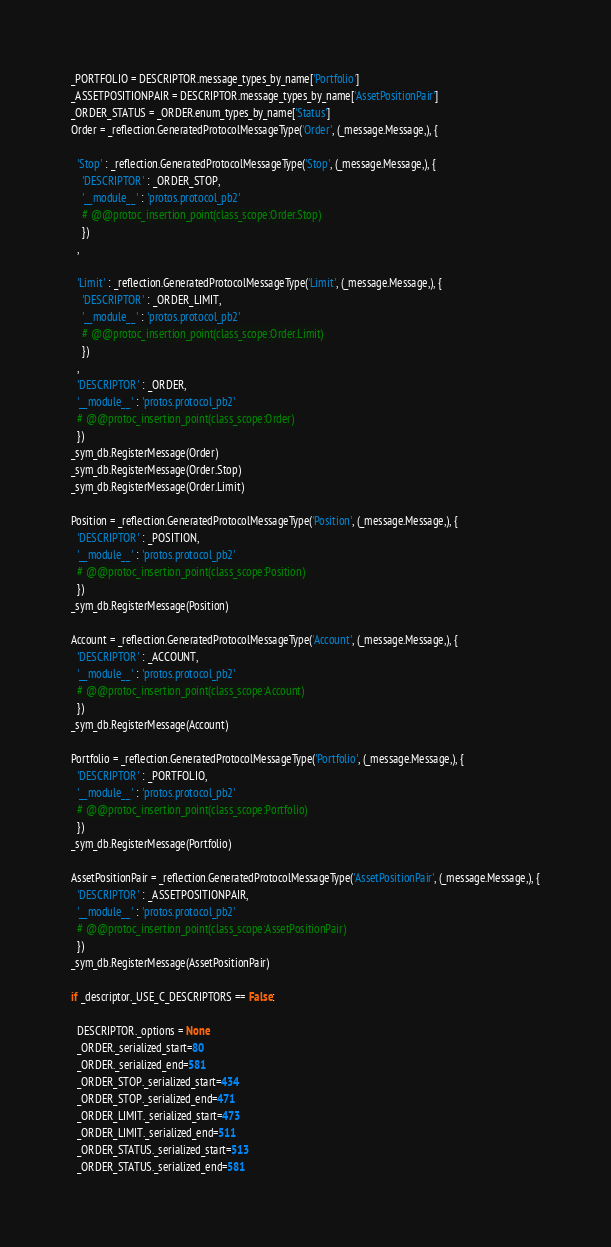Convert code to text. <code><loc_0><loc_0><loc_500><loc_500><_Python_>_PORTFOLIO = DESCRIPTOR.message_types_by_name['Portfolio']
_ASSETPOSITIONPAIR = DESCRIPTOR.message_types_by_name['AssetPositionPair']
_ORDER_STATUS = _ORDER.enum_types_by_name['Status']
Order = _reflection.GeneratedProtocolMessageType('Order', (_message.Message,), {

  'Stop' : _reflection.GeneratedProtocolMessageType('Stop', (_message.Message,), {
    'DESCRIPTOR' : _ORDER_STOP,
    '__module__' : 'protos.protocol_pb2'
    # @@protoc_insertion_point(class_scope:Order.Stop)
    })
  ,

  'Limit' : _reflection.GeneratedProtocolMessageType('Limit', (_message.Message,), {
    'DESCRIPTOR' : _ORDER_LIMIT,
    '__module__' : 'protos.protocol_pb2'
    # @@protoc_insertion_point(class_scope:Order.Limit)
    })
  ,
  'DESCRIPTOR' : _ORDER,
  '__module__' : 'protos.protocol_pb2'
  # @@protoc_insertion_point(class_scope:Order)
  })
_sym_db.RegisterMessage(Order)
_sym_db.RegisterMessage(Order.Stop)
_sym_db.RegisterMessage(Order.Limit)

Position = _reflection.GeneratedProtocolMessageType('Position', (_message.Message,), {
  'DESCRIPTOR' : _POSITION,
  '__module__' : 'protos.protocol_pb2'
  # @@protoc_insertion_point(class_scope:Position)
  })
_sym_db.RegisterMessage(Position)

Account = _reflection.GeneratedProtocolMessageType('Account', (_message.Message,), {
  'DESCRIPTOR' : _ACCOUNT,
  '__module__' : 'protos.protocol_pb2'
  # @@protoc_insertion_point(class_scope:Account)
  })
_sym_db.RegisterMessage(Account)

Portfolio = _reflection.GeneratedProtocolMessageType('Portfolio', (_message.Message,), {
  'DESCRIPTOR' : _PORTFOLIO,
  '__module__' : 'protos.protocol_pb2'
  # @@protoc_insertion_point(class_scope:Portfolio)
  })
_sym_db.RegisterMessage(Portfolio)

AssetPositionPair = _reflection.GeneratedProtocolMessageType('AssetPositionPair', (_message.Message,), {
  'DESCRIPTOR' : _ASSETPOSITIONPAIR,
  '__module__' : 'protos.protocol_pb2'
  # @@protoc_insertion_point(class_scope:AssetPositionPair)
  })
_sym_db.RegisterMessage(AssetPositionPair)

if _descriptor._USE_C_DESCRIPTORS == False:

  DESCRIPTOR._options = None
  _ORDER._serialized_start=80
  _ORDER._serialized_end=581
  _ORDER_STOP._serialized_start=434
  _ORDER_STOP._serialized_end=471
  _ORDER_LIMIT._serialized_start=473
  _ORDER_LIMIT._serialized_end=511
  _ORDER_STATUS._serialized_start=513
  _ORDER_STATUS._serialized_end=581</code> 